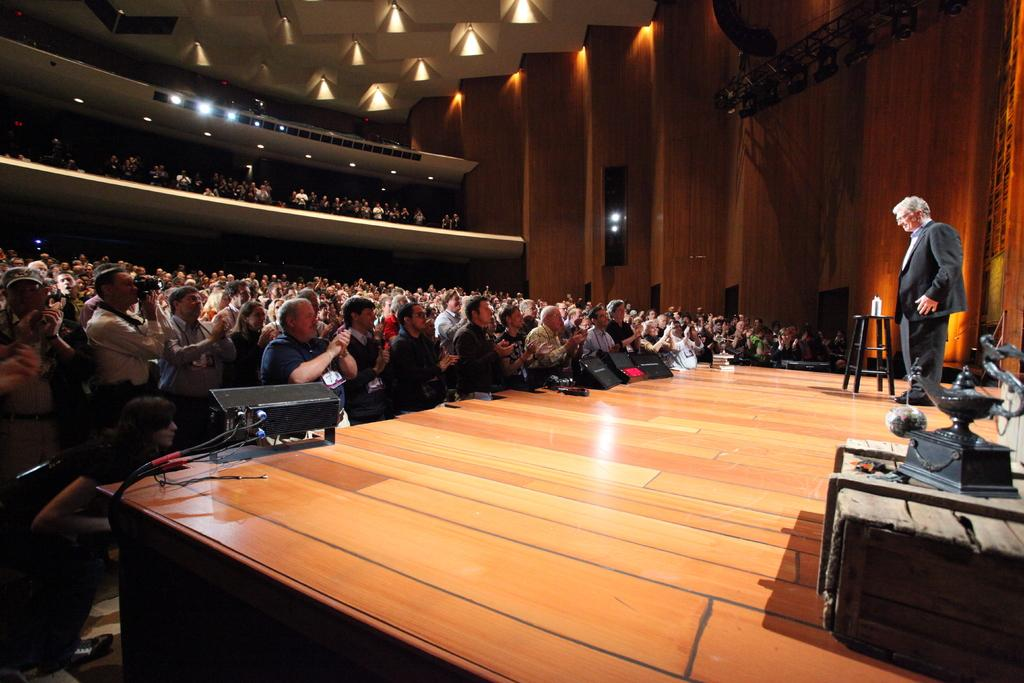How many people are in the image? There is a group of persons in the image. What is the man in the image doing? The man is standing on the floor. What can be seen illuminating the scene in the image? There are lights visible in the image. What piece of furniture is present in the image? There is a stool in the image. What type of structure is visible in the background of the image? There is a wall in the image. What riddle is the grandfather telling the group of persons in the image? There is no grandfather or riddle present in the image; it only shows a group of persons and a man standing on the floor. 